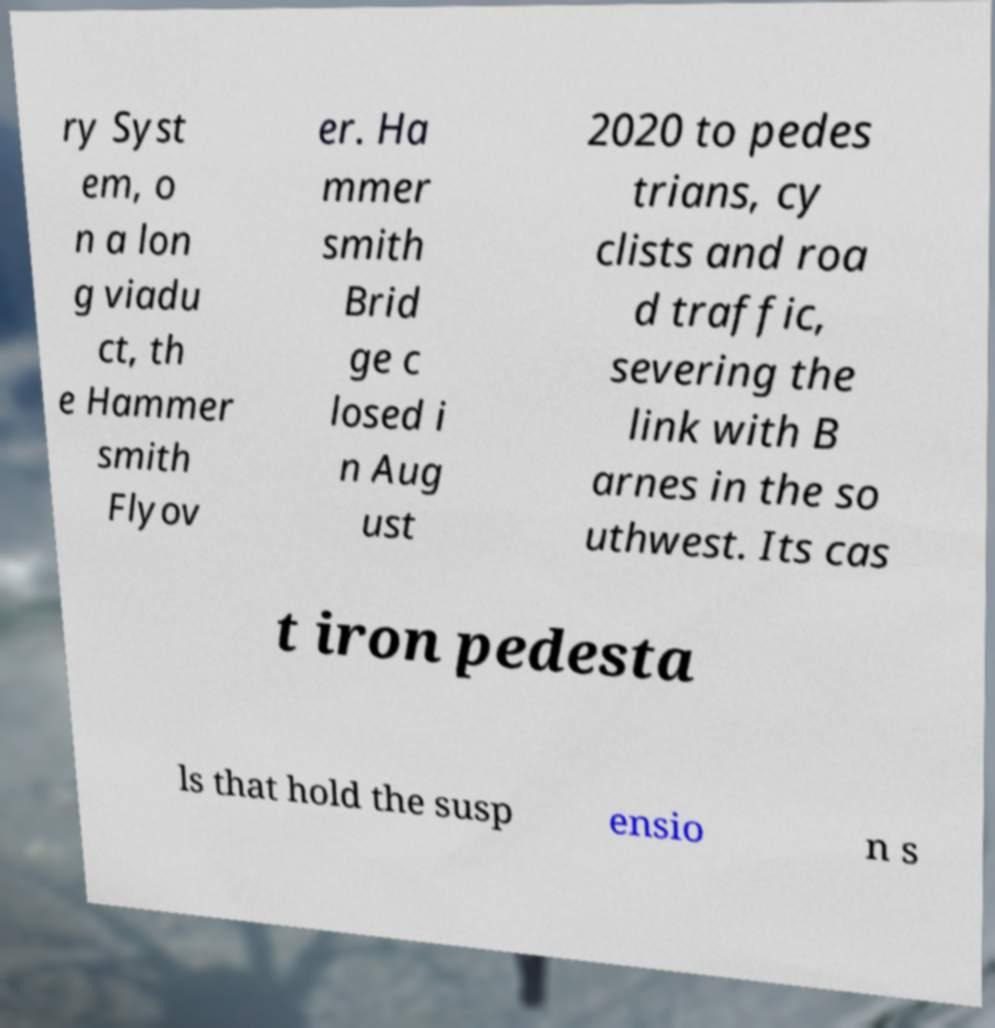For documentation purposes, I need the text within this image transcribed. Could you provide that? ry Syst em, o n a lon g viadu ct, th e Hammer smith Flyov er. Ha mmer smith Brid ge c losed i n Aug ust 2020 to pedes trians, cy clists and roa d traffic, severing the link with B arnes in the so uthwest. Its cas t iron pedesta ls that hold the susp ensio n s 